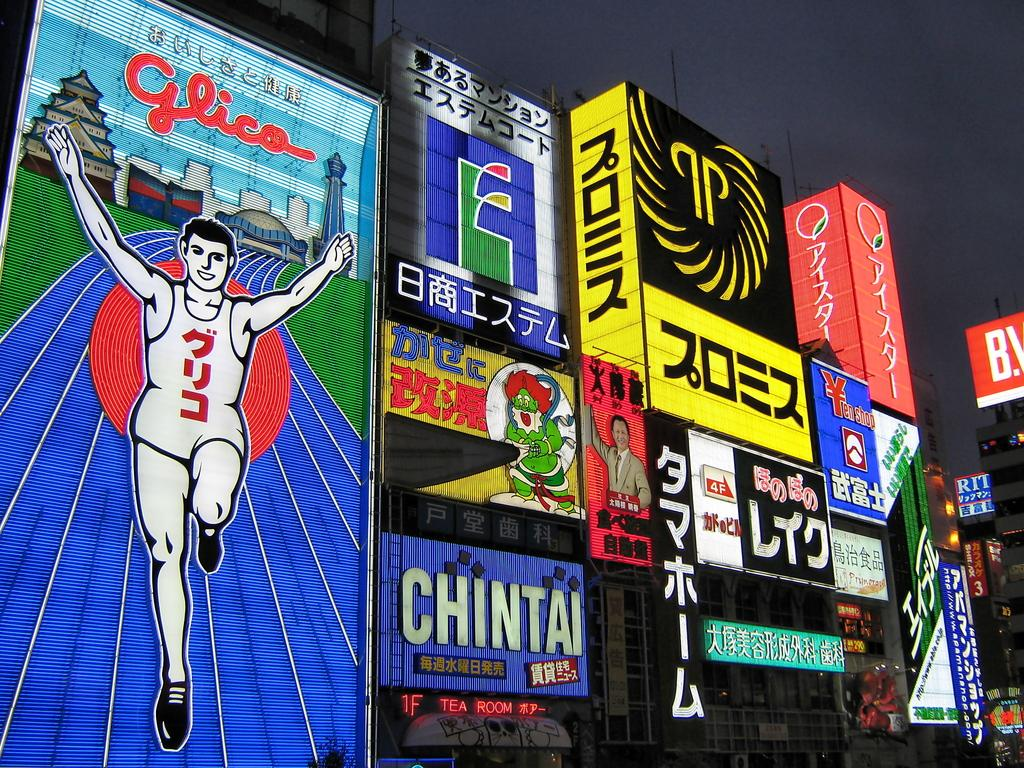<image>
Describe the image concisely. Signs and banners decorate the walls in this Japanese city including one reading Glico 